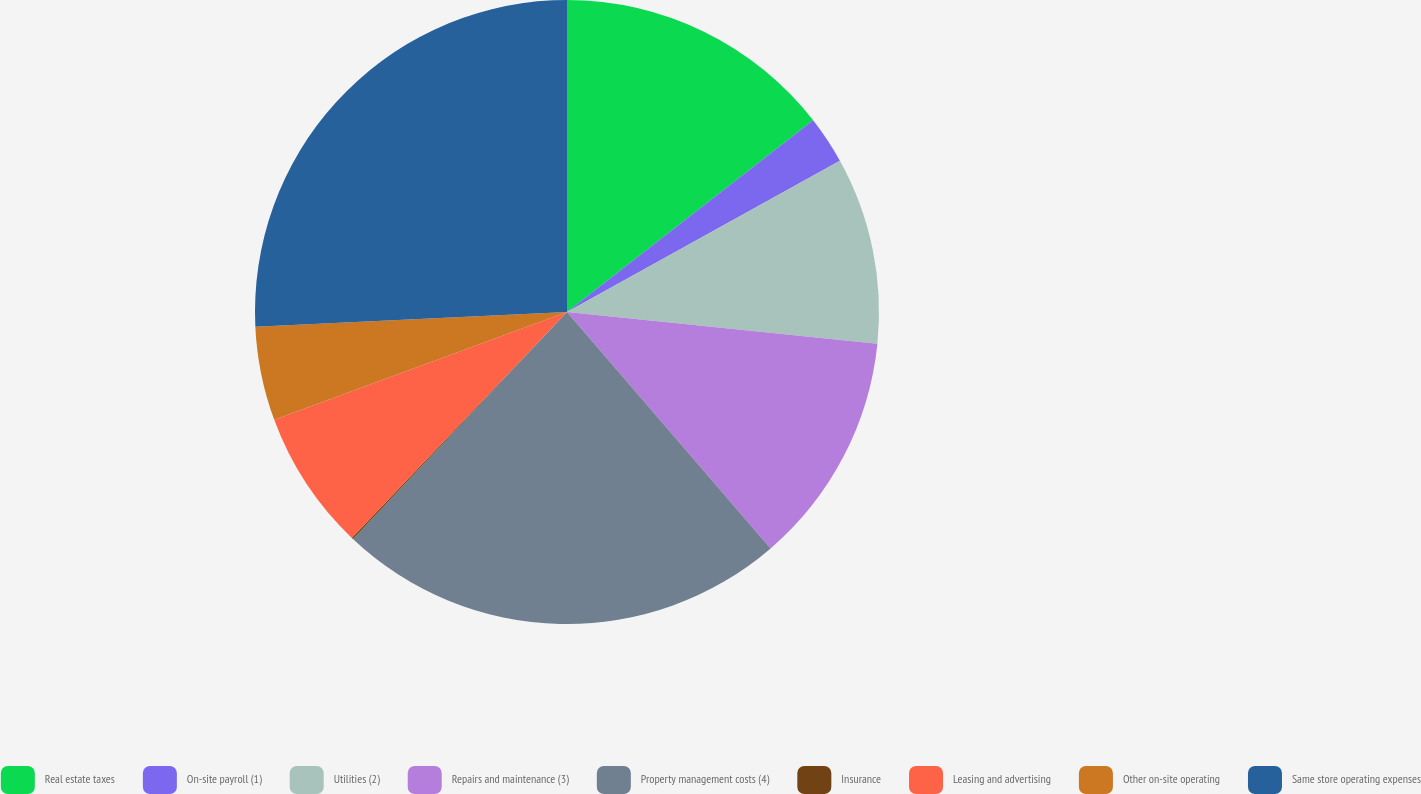Convert chart. <chart><loc_0><loc_0><loc_500><loc_500><pie_chart><fcel>Real estate taxes<fcel>On-site payroll (1)<fcel>Utilities (2)<fcel>Repairs and maintenance (3)<fcel>Property management costs (4)<fcel>Insurance<fcel>Leasing and advertising<fcel>Other on-site operating<fcel>Same store operating expenses<nl><fcel>14.47%<fcel>2.48%<fcel>9.67%<fcel>12.07%<fcel>23.35%<fcel>0.08%<fcel>7.27%<fcel>4.87%<fcel>25.75%<nl></chart> 